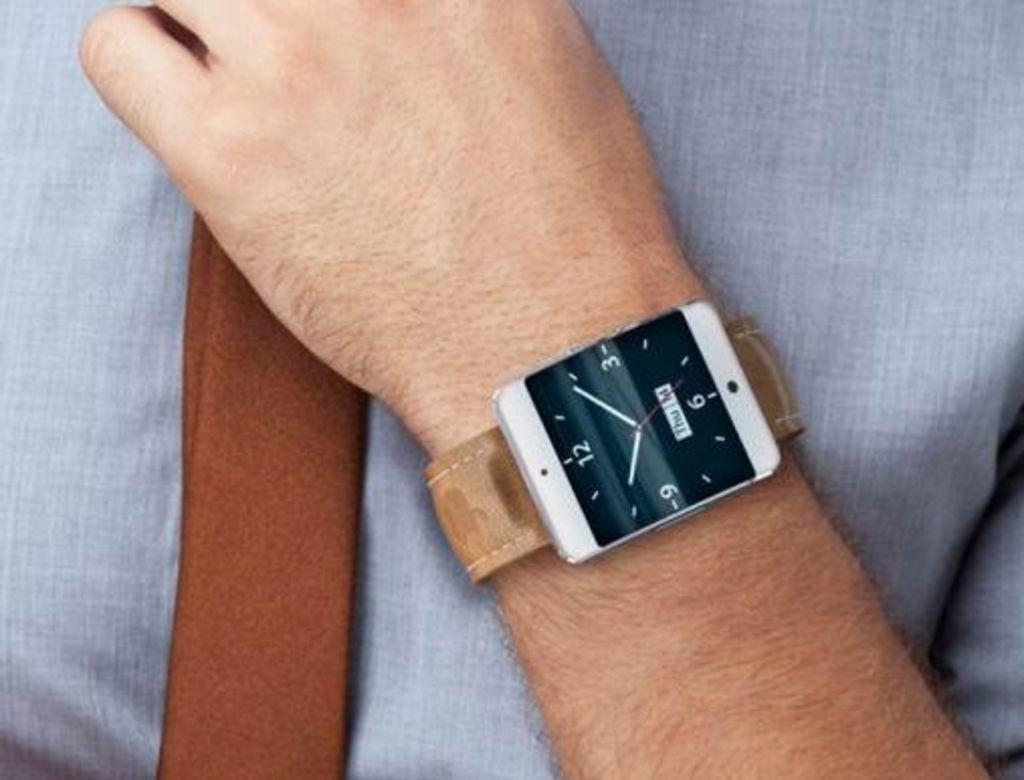<image>
Offer a succinct explanation of the picture presented. A man wearing a watch that displays the date as being Thursday the 14th. 